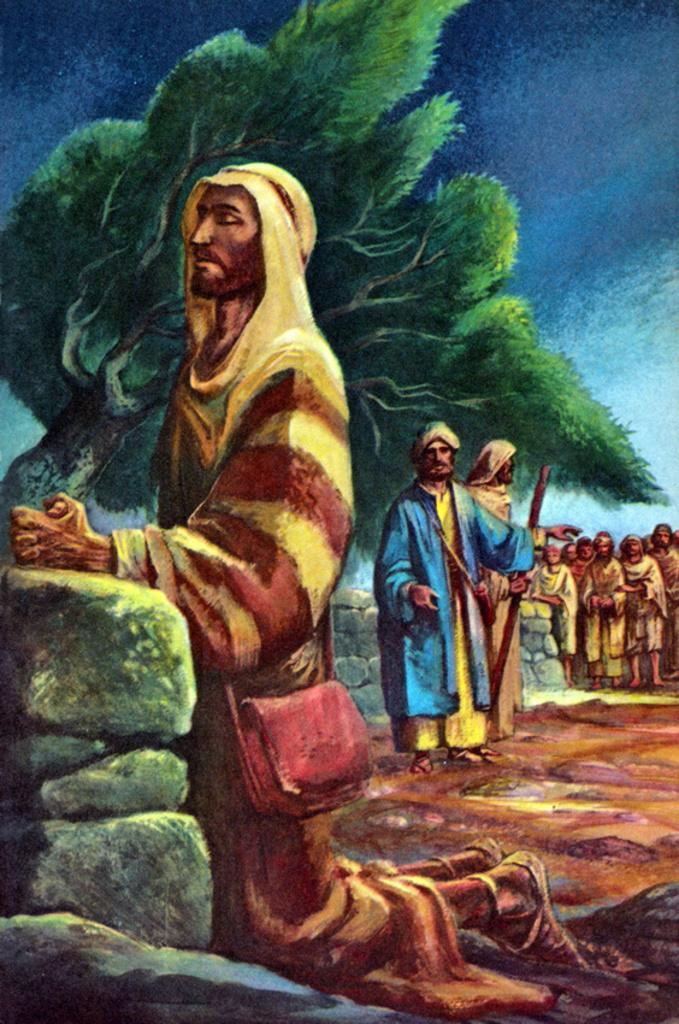What is the main subject of the image? There is a painting in the image. What is happening in the painting? The painting depicts people standing and watching. What natural elements can be seen in the painting? There is a tree and the sky visible in the painting. What effect does the painting have on the harmony of the room? The provided facts do not mention any information about the room or its harmony, so it is impossible to determine the effect of the painting on the room's harmony. 